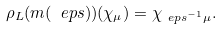Convert formula to latex. <formula><loc_0><loc_0><loc_500><loc_500>\rho _ { L } ( m ( \ e p s ) ) ( \chi _ { \mu } ) & = \chi _ { \ e p s ^ { - 1 } \mu } .</formula> 